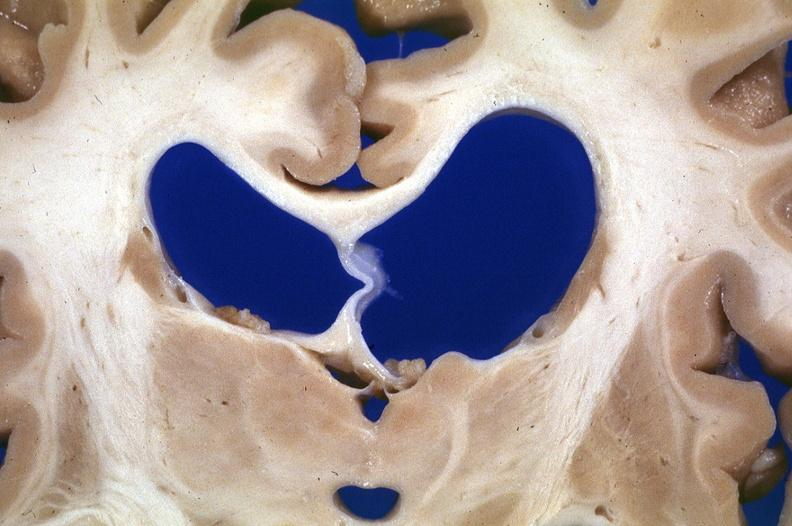does this image show brain, frontal lobe atrophy, pick 's disease?
Answer the question using a single word or phrase. Yes 